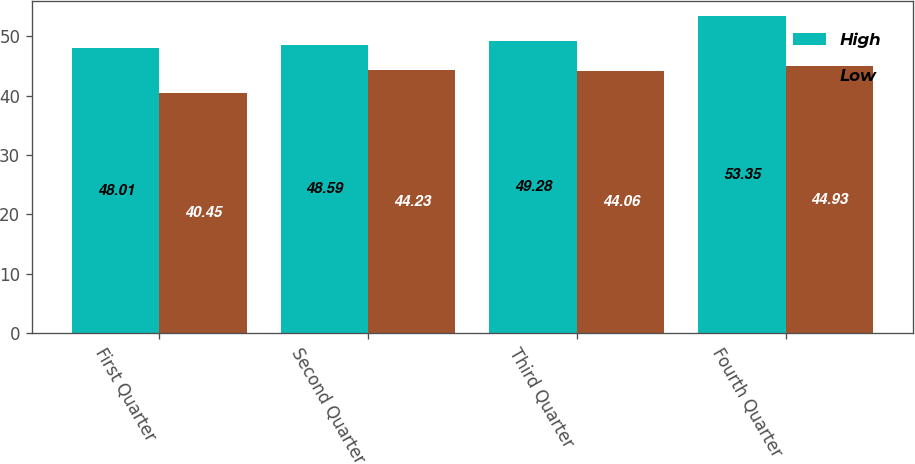Convert chart. <chart><loc_0><loc_0><loc_500><loc_500><stacked_bar_chart><ecel><fcel>First Quarter<fcel>Second Quarter<fcel>Third Quarter<fcel>Fourth Quarter<nl><fcel>High<fcel>48.01<fcel>48.59<fcel>49.28<fcel>53.35<nl><fcel>Low<fcel>40.45<fcel>44.23<fcel>44.06<fcel>44.93<nl></chart> 